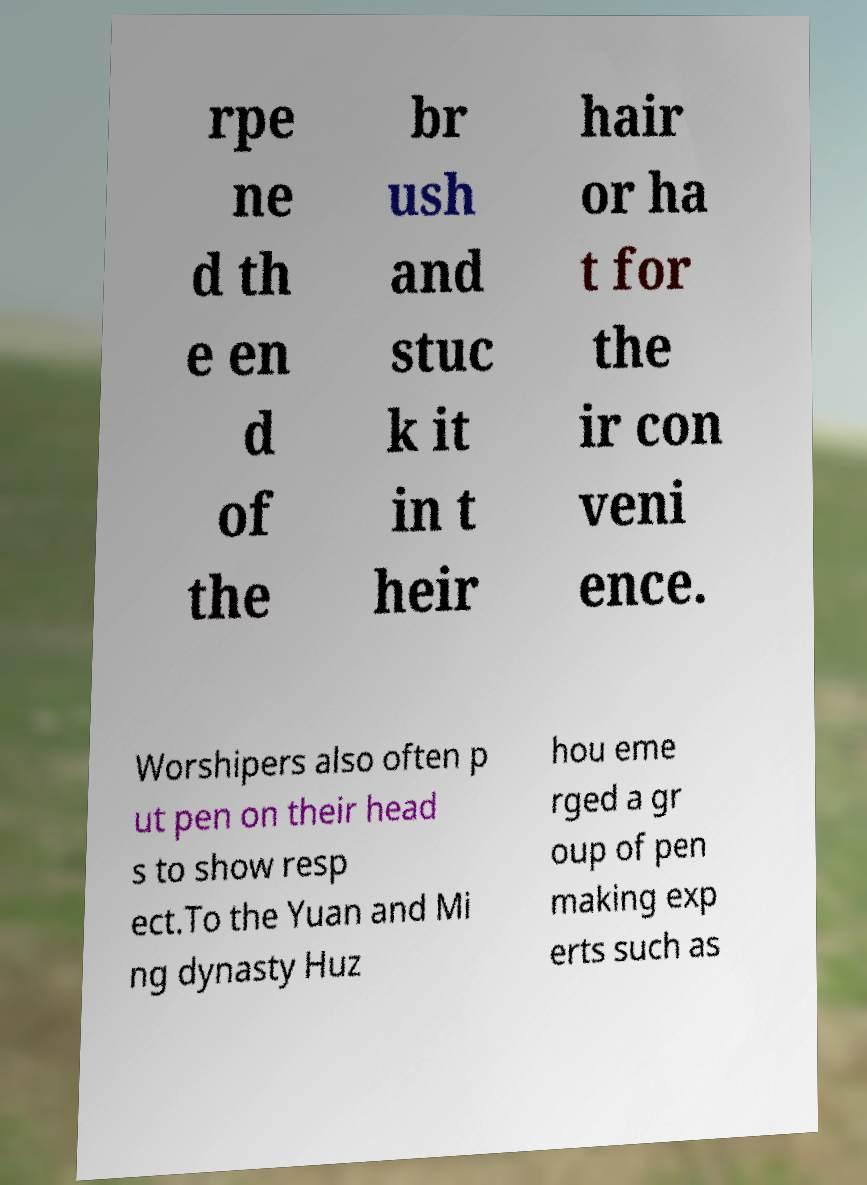For documentation purposes, I need the text within this image transcribed. Could you provide that? rpe ne d th e en d of the br ush and stuc k it in t heir hair or ha t for the ir con veni ence. Worshipers also often p ut pen on their head s to show resp ect.To the Yuan and Mi ng dynasty Huz hou eme rged a gr oup of pen making exp erts such as 